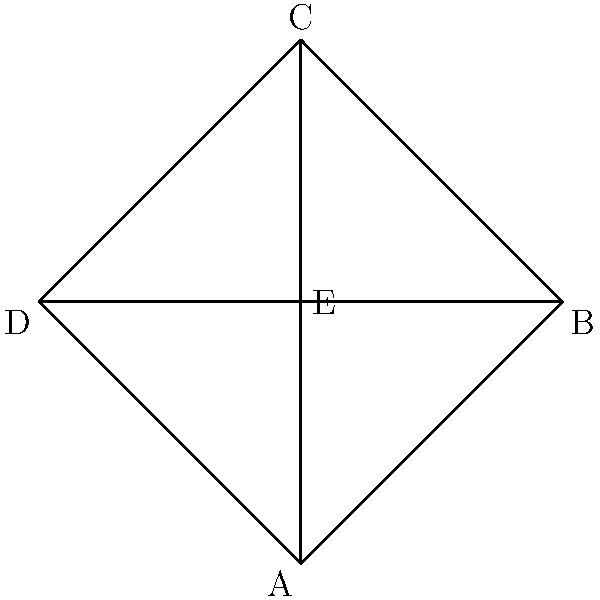Emory University's organizational chart shows connections between five academic departments: A, B, C, D, and E. Each department must be assigned a unique color, and connected departments cannot share the same color. What is the minimum number of colors needed to properly color this organizational chart? To determine the minimum number of colors needed, we'll use the concept of graph coloring:

1. Analyze the connections:
   - Department E is connected to all other departments (A, B, C, D).
   - Departments A, B, C, and D form a cycle, each connected to its two adjacent departments.

2. Start coloring:
   - Assign color 1 to department E.
   - Since E is connected to all others, we need different colors for A, B, C, and D.
   - We can alternate between two new colors (2 and 3) for A, B, C, and D:
     * A: color 2
     * B: color 3
     * C: color 2
     * D: color 3

3. Verify:
   - No two connected departments share the same color.
   - We used a total of 3 colors (1 for E, and 2 for the cycle ABCD).

4. Conclusion:
   The minimum number of colors needed is 3, as we cannot use fewer colors without adjacent departments sharing a color.
Answer: 3 colors 